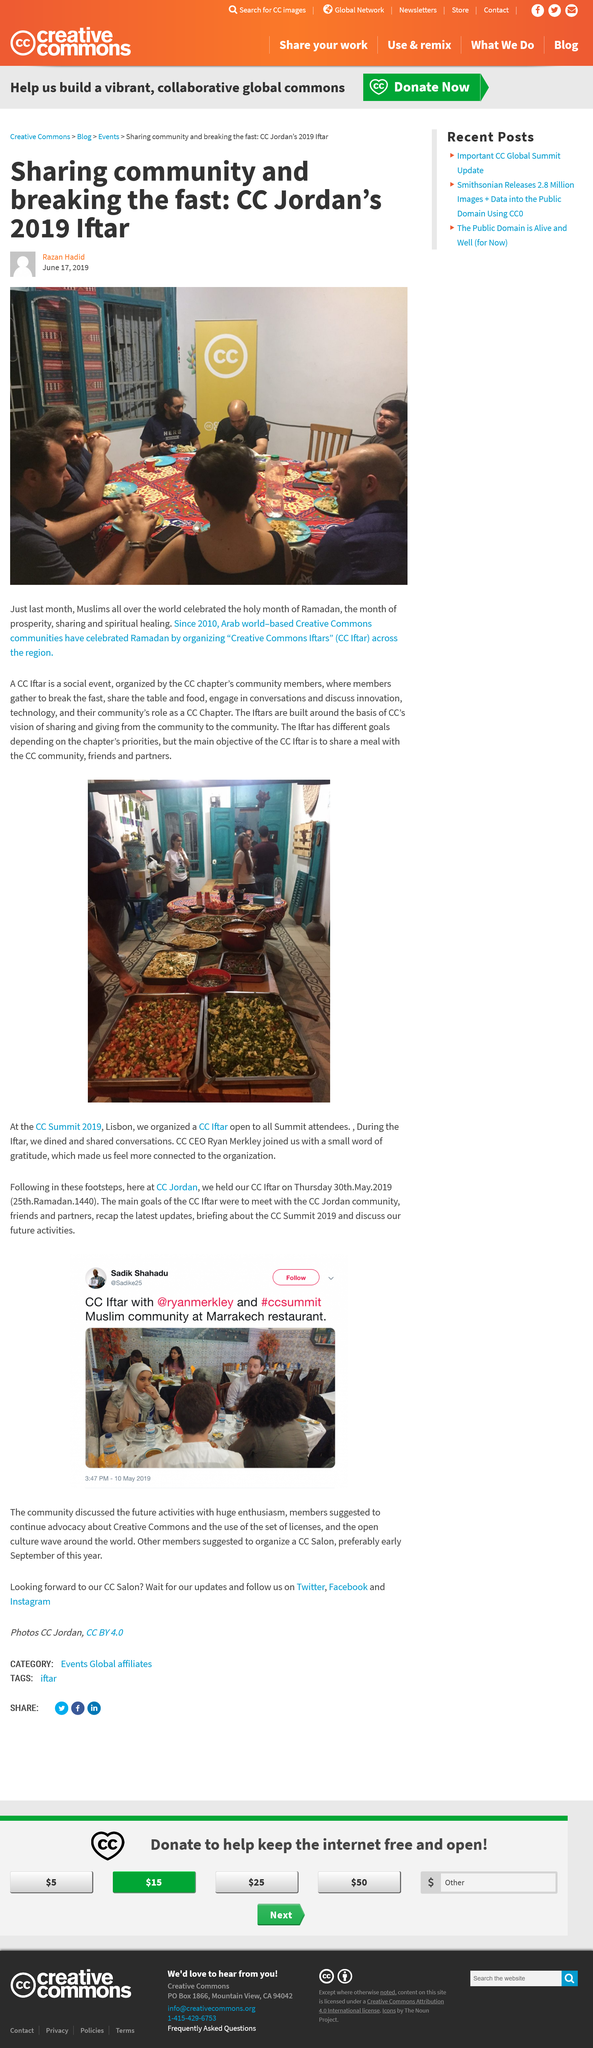Indicate a few pertinent items in this graphic. A CC Iftar is a social event that takes place during Ramadan. In May 2019, Muslims celebrated the holy month of Ramadan. The CC Iftar is designed to provide an opportunity for the CC community, friends, and partners to come together and share a meal, with the primary objective of fostering a sense of community and building relationships. 